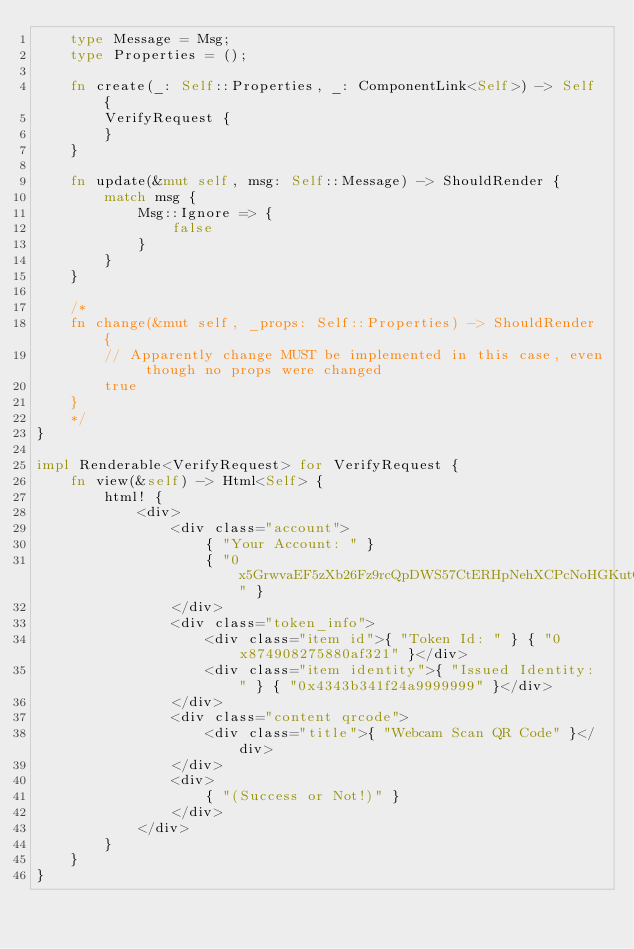Convert code to text. <code><loc_0><loc_0><loc_500><loc_500><_Rust_>    type Message = Msg;
    type Properties = ();

    fn create(_: Self::Properties, _: ComponentLink<Self>) -> Self {
        VerifyRequest {
        }
    }

    fn update(&mut self, msg: Self::Message) -> ShouldRender {
        match msg {
            Msg::Ignore => {
                false
            }
        }
    }
    
    /*
    fn change(&mut self, _props: Self::Properties) -> ShouldRender {
        // Apparently change MUST be implemented in this case, even though no props were changed
        true
    }
    */
}

impl Renderable<VerifyRequest> for VerifyRequest {
    fn view(&self) -> Html<Self> {
        html! {
            <div>
                <div class="account">
                    { "Your Account: " }
                    { "0x5GrwvaEF5zXb26Fz9rcQpDWS57CtERHpNehXCPcNoHGKutQY" }
                </div>
                <div class="token_info">
                    <div class="item id">{ "Token Id: " } { "0x874908275880af321" }</div>
                    <div class="item identity">{ "Issued Identity: " } { "0x4343b341f24a9999999" }</div>
                </div>
                <div class="content qrcode">
                    <div class="title">{ "Webcam Scan QR Code" }</div>
                </div>
                <div>
                    { "(Success or Not!)" }
                </div>
            </div>
        }
    }
}

</code> 